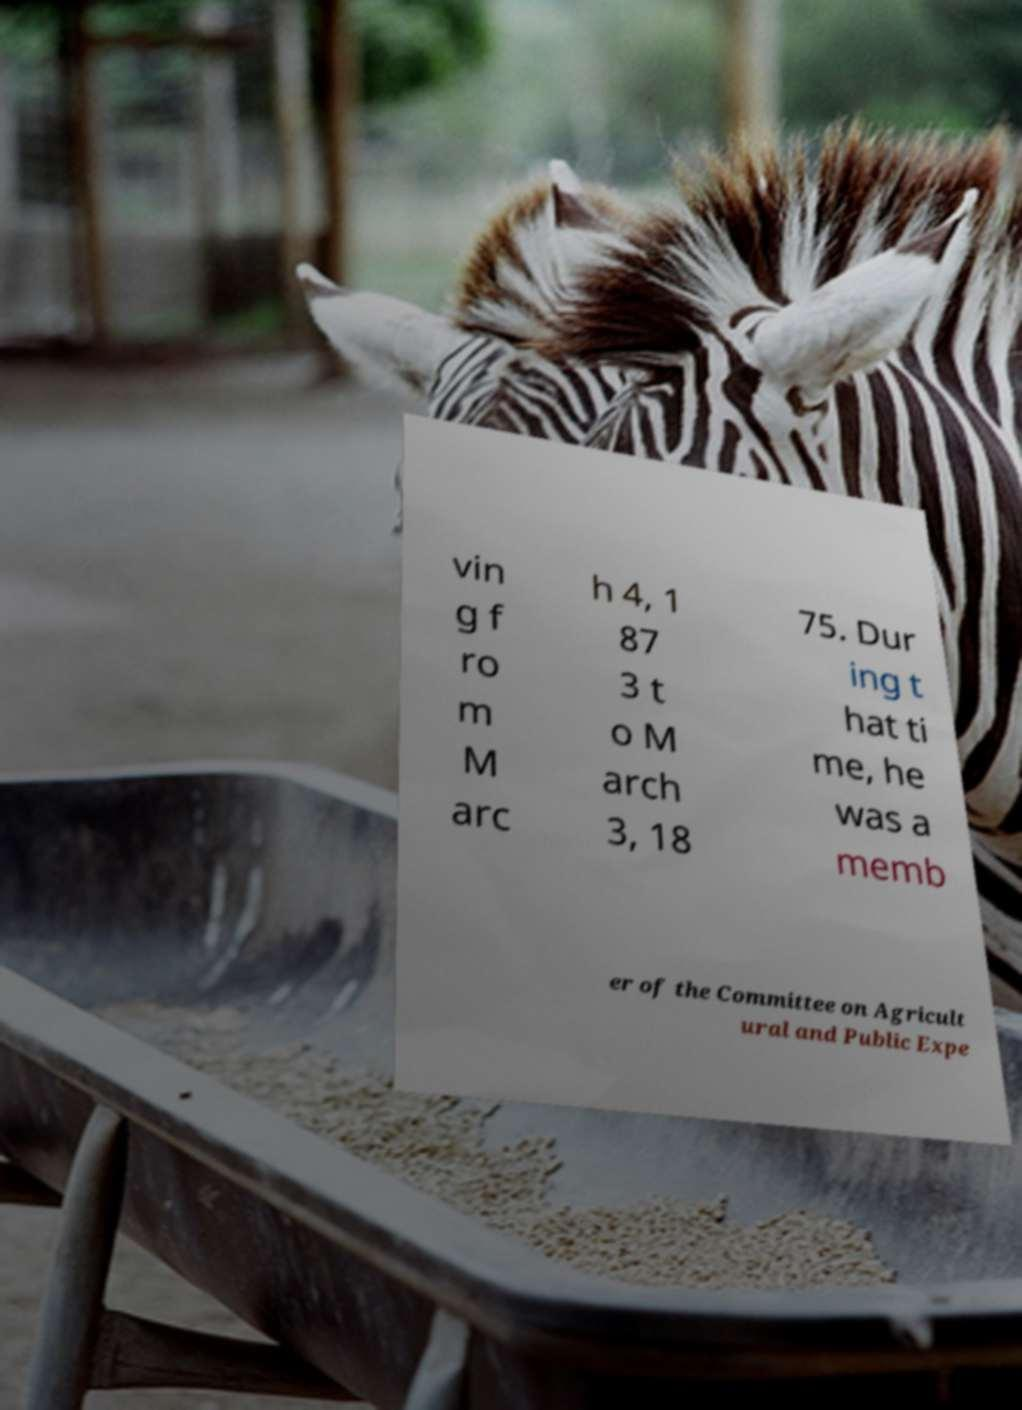Could you assist in decoding the text presented in this image and type it out clearly? vin g f ro m M arc h 4, 1 87 3 t o M arch 3, 18 75. Dur ing t hat ti me, he was a memb er of the Committee on Agricult ural and Public Expe 